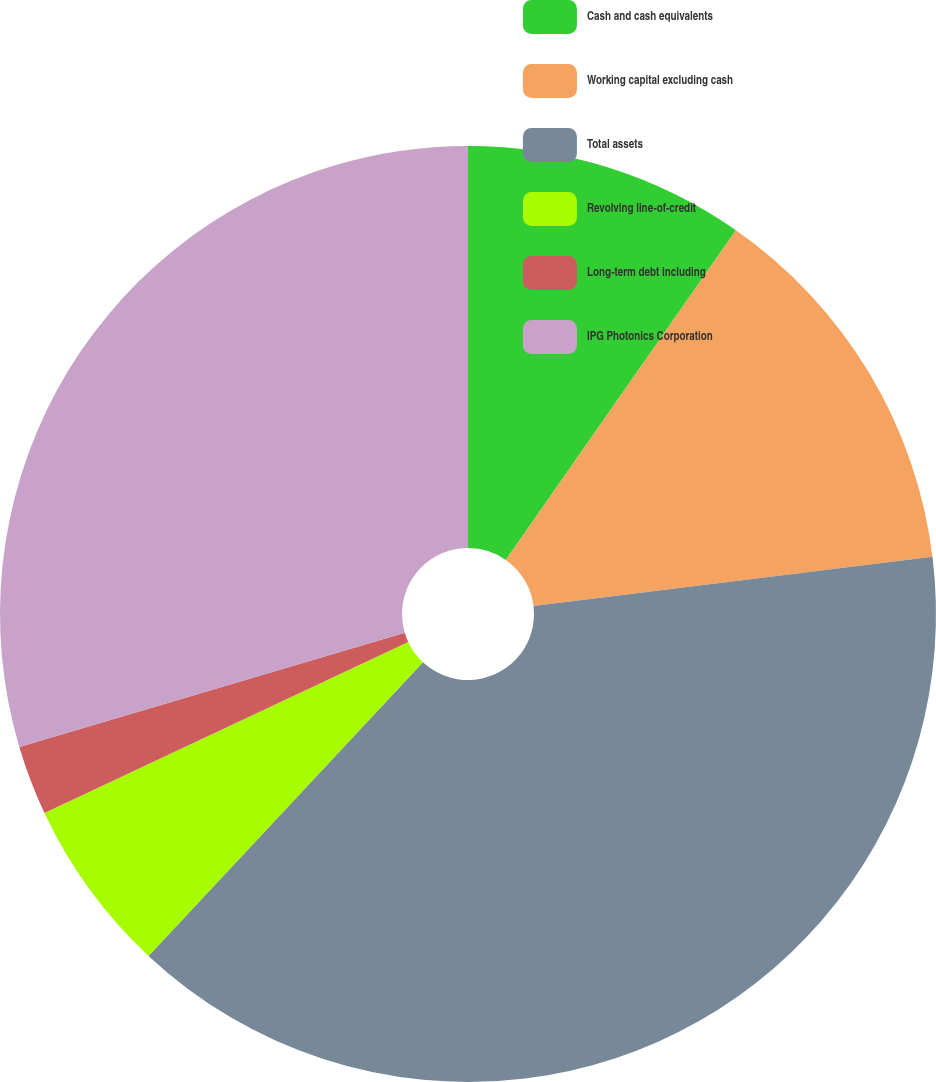Convert chart to OTSL. <chart><loc_0><loc_0><loc_500><loc_500><pie_chart><fcel>Cash and cash equivalents<fcel>Working capital excluding cash<fcel>Total assets<fcel>Revolving line-of-credit<fcel>Long-term debt including<fcel>IPG Photonics Corporation<nl><fcel>9.7%<fcel>13.35%<fcel>38.91%<fcel>6.05%<fcel>2.4%<fcel>29.59%<nl></chart> 